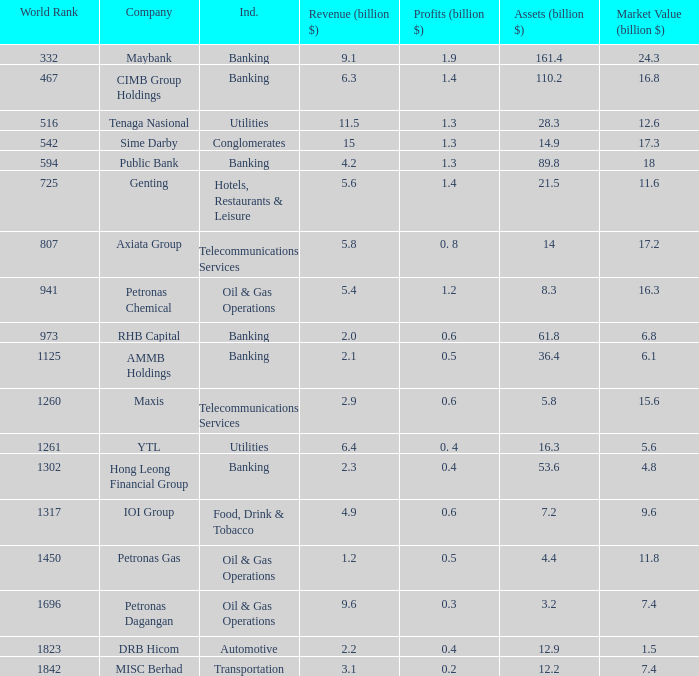Name the industry for revenue being 2.1 Banking. Would you be able to parse every entry in this table? {'header': ['World Rank', 'Company', 'Ind.', 'Revenue (billion $)', 'Profits (billion $)', 'Assets (billion $)', 'Market Value (billion $)'], 'rows': [['332', 'Maybank', 'Banking', '9.1', '1.9', '161.4', '24.3'], ['467', 'CIMB Group Holdings', 'Banking', '6.3', '1.4', '110.2', '16.8'], ['516', 'Tenaga Nasional', 'Utilities', '11.5', '1.3', '28.3', '12.6'], ['542', 'Sime Darby', 'Conglomerates', '15', '1.3', '14.9', '17.3'], ['594', 'Public Bank', 'Banking', '4.2', '1.3', '89.8', '18'], ['725', 'Genting', 'Hotels, Restaurants & Leisure', '5.6', '1.4', '21.5', '11.6'], ['807', 'Axiata Group', 'Telecommunications Services', '5.8', '0. 8', '14', '17.2'], ['941', 'Petronas Chemical', 'Oil & Gas Operations', '5.4', '1.2', '8.3', '16.3'], ['973', 'RHB Capital', 'Banking', '2.0', '0.6', '61.8', '6.8'], ['1125', 'AMMB Holdings', 'Banking', '2.1', '0.5', '36.4', '6.1'], ['1260', 'Maxis', 'Telecommunications Services', '2.9', '0.6', '5.8', '15.6'], ['1261', 'YTL', 'Utilities', '6.4', '0. 4', '16.3', '5.6'], ['1302', 'Hong Leong Financial Group', 'Banking', '2.3', '0.4', '53.6', '4.8'], ['1317', 'IOI Group', 'Food, Drink & Tobacco', '4.9', '0.6', '7.2', '9.6'], ['1450', 'Petronas Gas', 'Oil & Gas Operations', '1.2', '0.5', '4.4', '11.8'], ['1696', 'Petronas Dagangan', 'Oil & Gas Operations', '9.6', '0.3', '3.2', '7.4'], ['1823', 'DRB Hicom', 'Automotive', '2.2', '0.4', '12.9', '1.5'], ['1842', 'MISC Berhad', 'Transportation', '3.1', '0.2', '12.2', '7.4']]} 